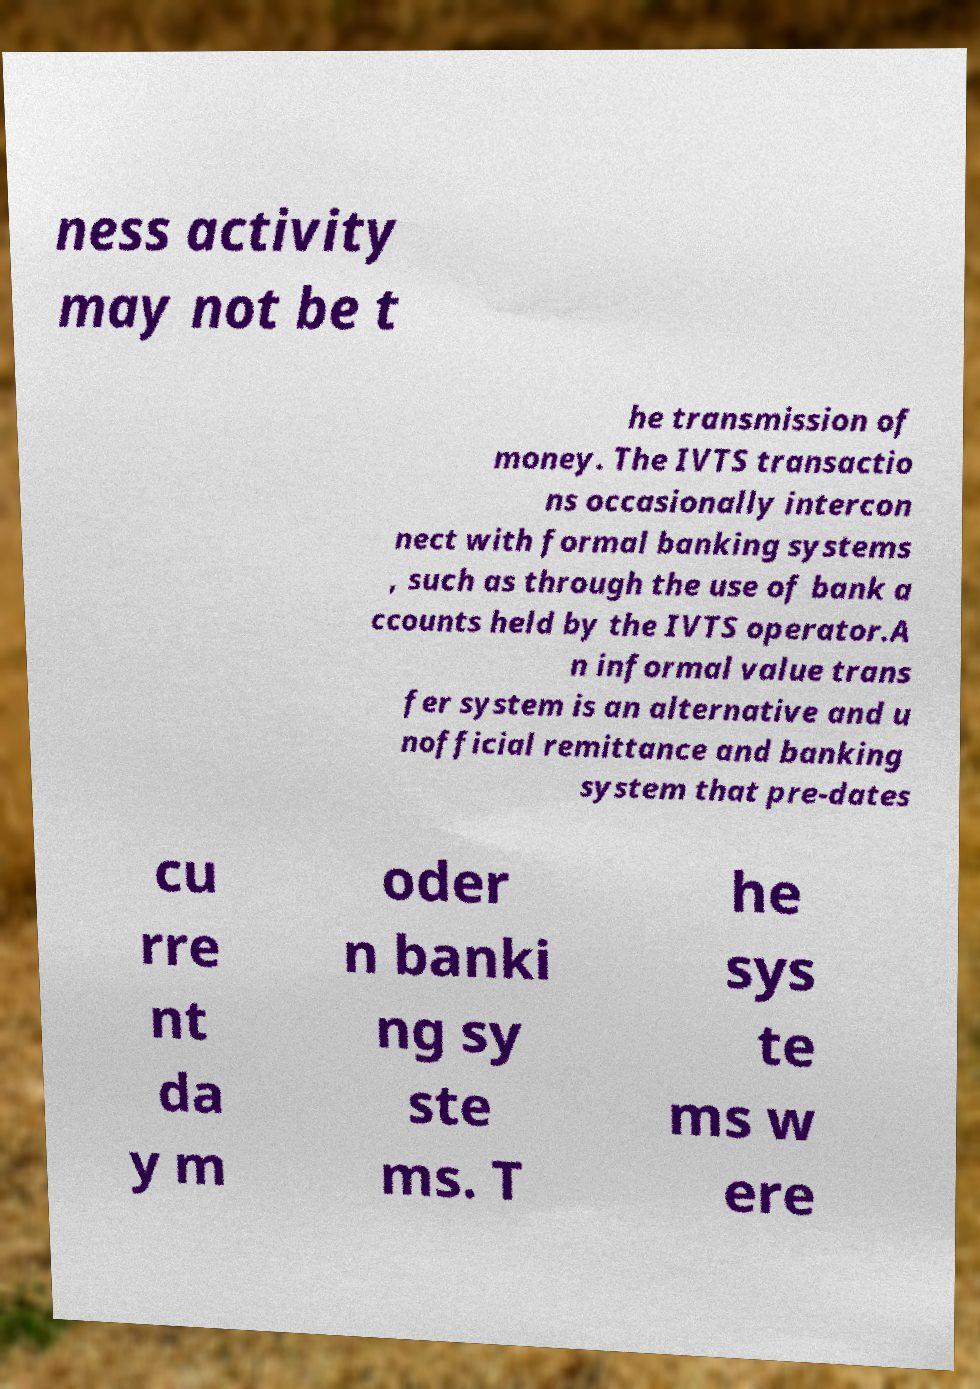Can you accurately transcribe the text from the provided image for me? ness activity may not be t he transmission of money. The IVTS transactio ns occasionally intercon nect with formal banking systems , such as through the use of bank a ccounts held by the IVTS operator.A n informal value trans fer system is an alternative and u nofficial remittance and banking system that pre-dates cu rre nt da y m oder n banki ng sy ste ms. T he sys te ms w ere 